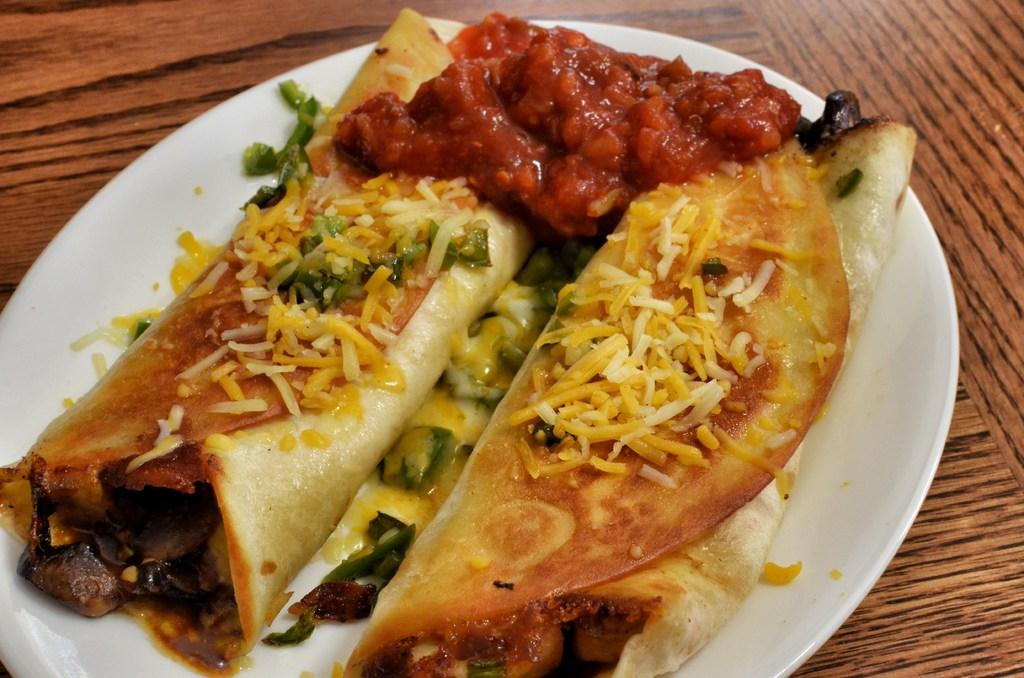What is the color of the plate in the image? The plate in the image is white. What is on the plate? The plate has food items on it. On what surface is the plate placed? The plate is placed on a wooden surface. How many fingers can be seen holding the cup in the image? There is no cup or fingers present in the image; it only features a white plate with food items on it. 